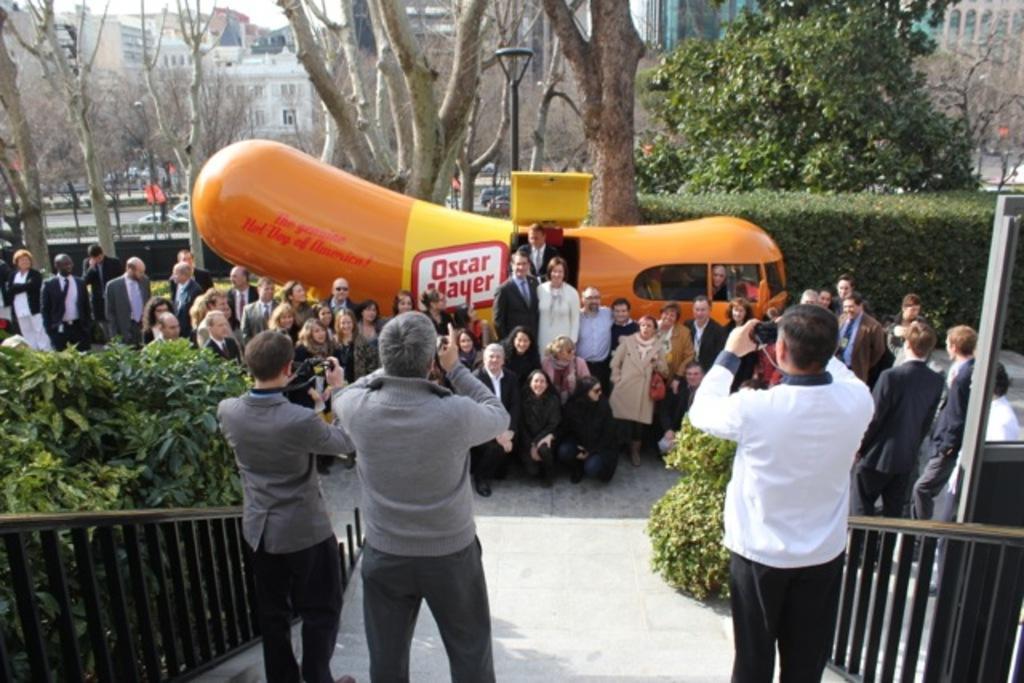Could you give a brief overview of what you see in this image? In the foreground of the picture there are people, plants, hand railing and staircase. In the middle of the picture we can see people, trees, plants, bugs like object and various things. In the background there are buildings, trees and sky. Towards left we can see vehicles and road 